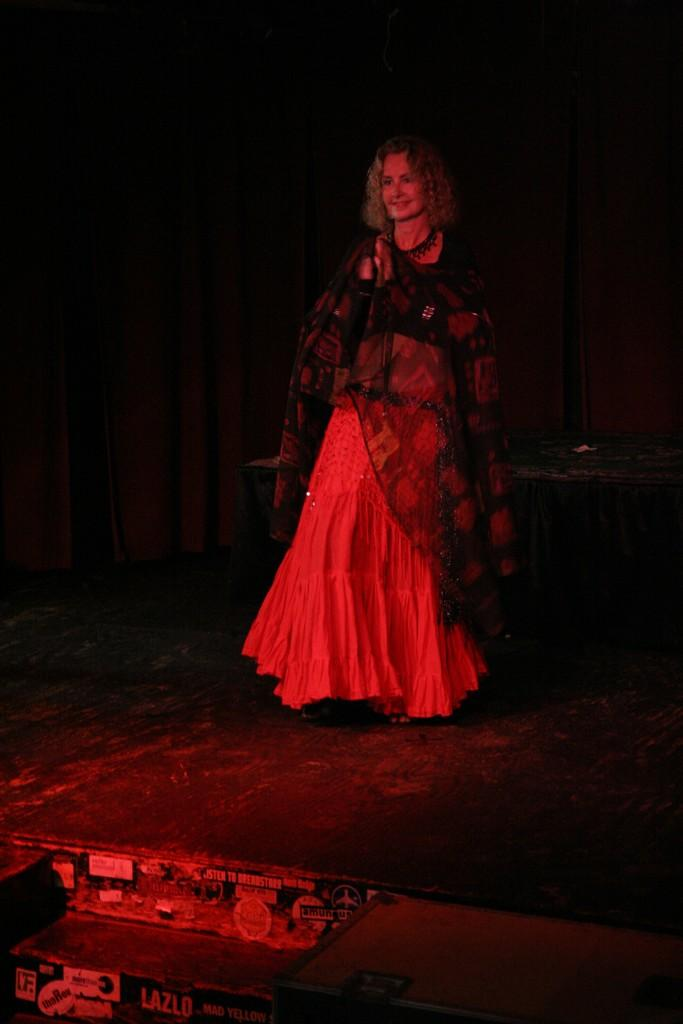Who is the main subject in the image? There is a woman in the center of the image. What is the woman doing in the image? The woman is standing and smiling. What can be seen in the front of the image? There is an object in the front of the image that is black in color. What type of objects are present with text written on them in the image? There are boards with text written on them in the image. Can you see any fog in the image? There is no fog visible in the image. What number is written on the boards in the image? The provided facts do not mention any specific numbers written on the boards in the image. 